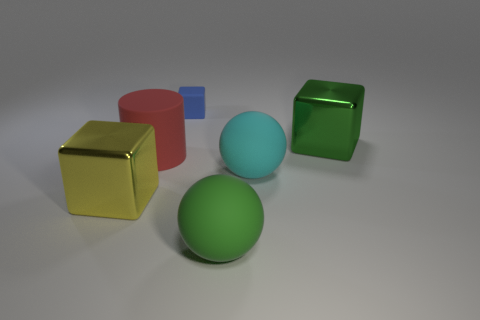Add 2 small blue shiny blocks. How many objects exist? 8 Subtract all cyan cylinders. Subtract all gray spheres. How many cylinders are left? 1 Subtract all balls. How many objects are left? 4 Subtract 0 gray cubes. How many objects are left? 6 Subtract all brown things. Subtract all blue objects. How many objects are left? 5 Add 4 big green blocks. How many big green blocks are left? 5 Add 1 small blue matte blocks. How many small blue matte blocks exist? 2 